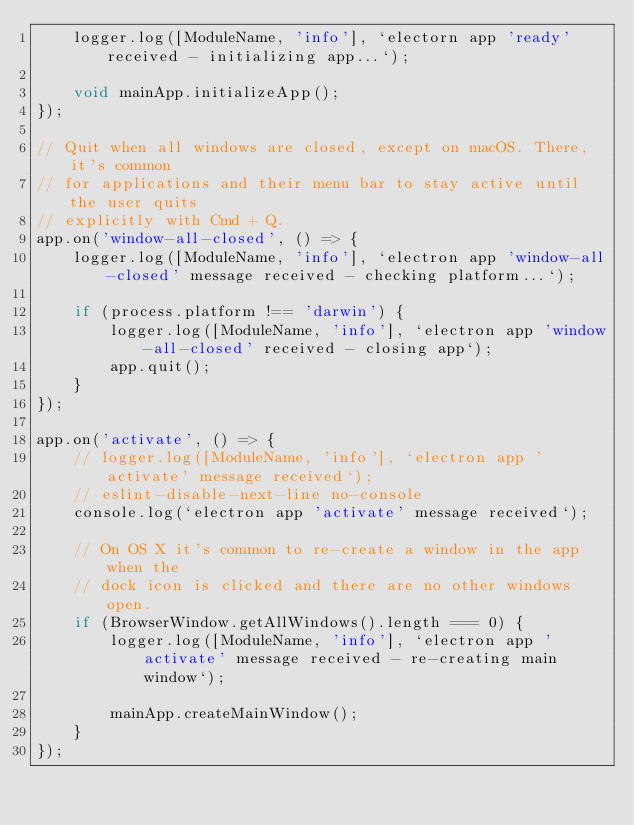<code> <loc_0><loc_0><loc_500><loc_500><_TypeScript_>    logger.log([ModuleName, 'info'], `electorn app 'ready' received - initializing app...`);

    void mainApp.initializeApp();
});

// Quit when all windows are closed, except on macOS. There, it's common
// for applications and their menu bar to stay active until the user quits
// explicitly with Cmd + Q.
app.on('window-all-closed', () => {
    logger.log([ModuleName, 'info'], `electron app 'window-all-closed' message received - checking platform...`);

    if (process.platform !== 'darwin') {
        logger.log([ModuleName, 'info'], `electron app 'window-all-closed' received - closing app`);
        app.quit();
    }
});

app.on('activate', () => {
    // logger.log([ModuleName, 'info'], `electron app 'activate' message received`);
    // eslint-disable-next-line no-console
    console.log(`electron app 'activate' message received`);

    // On OS X it's common to re-create a window in the app when the
    // dock icon is clicked and there are no other windows open.
    if (BrowserWindow.getAllWindows().length === 0) {
        logger.log([ModuleName, 'info'], `electron app 'activate' message received - re-creating main window`);

        mainApp.createMainWindow();
    }
});
</code> 